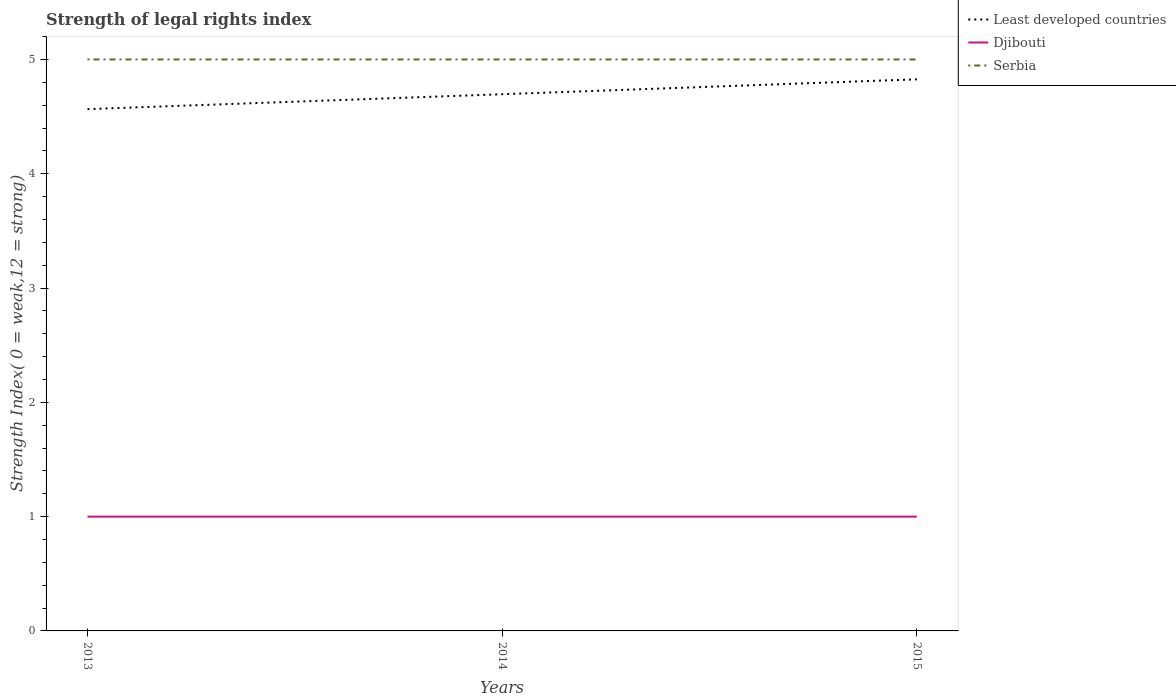Does the line corresponding to Least developed countries intersect with the line corresponding to Djibouti?
Provide a succinct answer. No. Is the number of lines equal to the number of legend labels?
Offer a very short reply. Yes. Across all years, what is the maximum strength index in Djibouti?
Provide a short and direct response. 1. What is the total strength index in Least developed countries in the graph?
Give a very brief answer. -0.26. What is the difference between the highest and the second highest strength index in Least developed countries?
Give a very brief answer. 0.26. What is the difference between the highest and the lowest strength index in Djibouti?
Give a very brief answer. 0. Is the strength index in Least developed countries strictly greater than the strength index in Djibouti over the years?
Ensure brevity in your answer.  No. How many lines are there?
Ensure brevity in your answer.  3. How many years are there in the graph?
Ensure brevity in your answer.  3. Does the graph contain any zero values?
Your answer should be compact. No. Where does the legend appear in the graph?
Your answer should be compact. Top right. How many legend labels are there?
Give a very brief answer. 3. What is the title of the graph?
Keep it short and to the point. Strength of legal rights index. Does "Caribbean small states" appear as one of the legend labels in the graph?
Offer a terse response. No. What is the label or title of the X-axis?
Your answer should be very brief. Years. What is the label or title of the Y-axis?
Offer a terse response. Strength Index( 0 = weak,12 = strong). What is the Strength Index( 0 = weak,12 = strong) in Least developed countries in 2013?
Your response must be concise. 4.57. What is the Strength Index( 0 = weak,12 = strong) in Djibouti in 2013?
Your answer should be very brief. 1. What is the Strength Index( 0 = weak,12 = strong) of Least developed countries in 2014?
Offer a very short reply. 4.7. What is the Strength Index( 0 = weak,12 = strong) in Serbia in 2014?
Give a very brief answer. 5. What is the Strength Index( 0 = weak,12 = strong) in Least developed countries in 2015?
Keep it short and to the point. 4.83. What is the Strength Index( 0 = weak,12 = strong) in Djibouti in 2015?
Your answer should be compact. 1. Across all years, what is the maximum Strength Index( 0 = weak,12 = strong) in Least developed countries?
Offer a very short reply. 4.83. Across all years, what is the maximum Strength Index( 0 = weak,12 = strong) of Djibouti?
Provide a short and direct response. 1. Across all years, what is the maximum Strength Index( 0 = weak,12 = strong) of Serbia?
Your answer should be very brief. 5. Across all years, what is the minimum Strength Index( 0 = weak,12 = strong) of Least developed countries?
Provide a succinct answer. 4.57. Across all years, what is the minimum Strength Index( 0 = weak,12 = strong) in Djibouti?
Ensure brevity in your answer.  1. What is the total Strength Index( 0 = weak,12 = strong) in Least developed countries in the graph?
Offer a terse response. 14.09. What is the total Strength Index( 0 = weak,12 = strong) in Djibouti in the graph?
Provide a short and direct response. 3. What is the total Strength Index( 0 = weak,12 = strong) of Serbia in the graph?
Give a very brief answer. 15. What is the difference between the Strength Index( 0 = weak,12 = strong) in Least developed countries in 2013 and that in 2014?
Provide a succinct answer. -0.13. What is the difference between the Strength Index( 0 = weak,12 = strong) in Djibouti in 2013 and that in 2014?
Make the answer very short. 0. What is the difference between the Strength Index( 0 = weak,12 = strong) of Least developed countries in 2013 and that in 2015?
Make the answer very short. -0.26. What is the difference between the Strength Index( 0 = weak,12 = strong) of Serbia in 2013 and that in 2015?
Keep it short and to the point. 0. What is the difference between the Strength Index( 0 = weak,12 = strong) in Least developed countries in 2014 and that in 2015?
Your answer should be very brief. -0.13. What is the difference between the Strength Index( 0 = weak,12 = strong) of Djibouti in 2014 and that in 2015?
Provide a succinct answer. 0. What is the difference between the Strength Index( 0 = weak,12 = strong) in Least developed countries in 2013 and the Strength Index( 0 = weak,12 = strong) in Djibouti in 2014?
Offer a terse response. 3.57. What is the difference between the Strength Index( 0 = weak,12 = strong) in Least developed countries in 2013 and the Strength Index( 0 = weak,12 = strong) in Serbia in 2014?
Your answer should be compact. -0.43. What is the difference between the Strength Index( 0 = weak,12 = strong) in Least developed countries in 2013 and the Strength Index( 0 = weak,12 = strong) in Djibouti in 2015?
Your response must be concise. 3.57. What is the difference between the Strength Index( 0 = weak,12 = strong) in Least developed countries in 2013 and the Strength Index( 0 = weak,12 = strong) in Serbia in 2015?
Offer a terse response. -0.43. What is the difference between the Strength Index( 0 = weak,12 = strong) in Least developed countries in 2014 and the Strength Index( 0 = weak,12 = strong) in Djibouti in 2015?
Offer a terse response. 3.7. What is the difference between the Strength Index( 0 = weak,12 = strong) in Least developed countries in 2014 and the Strength Index( 0 = weak,12 = strong) in Serbia in 2015?
Offer a very short reply. -0.3. What is the difference between the Strength Index( 0 = weak,12 = strong) in Djibouti in 2014 and the Strength Index( 0 = weak,12 = strong) in Serbia in 2015?
Keep it short and to the point. -4. What is the average Strength Index( 0 = weak,12 = strong) in Least developed countries per year?
Keep it short and to the point. 4.7. What is the average Strength Index( 0 = weak,12 = strong) of Serbia per year?
Make the answer very short. 5. In the year 2013, what is the difference between the Strength Index( 0 = weak,12 = strong) in Least developed countries and Strength Index( 0 = weak,12 = strong) in Djibouti?
Provide a short and direct response. 3.57. In the year 2013, what is the difference between the Strength Index( 0 = weak,12 = strong) of Least developed countries and Strength Index( 0 = weak,12 = strong) of Serbia?
Ensure brevity in your answer.  -0.43. In the year 2014, what is the difference between the Strength Index( 0 = weak,12 = strong) in Least developed countries and Strength Index( 0 = weak,12 = strong) in Djibouti?
Keep it short and to the point. 3.7. In the year 2014, what is the difference between the Strength Index( 0 = weak,12 = strong) of Least developed countries and Strength Index( 0 = weak,12 = strong) of Serbia?
Your response must be concise. -0.3. In the year 2014, what is the difference between the Strength Index( 0 = weak,12 = strong) in Djibouti and Strength Index( 0 = weak,12 = strong) in Serbia?
Provide a short and direct response. -4. In the year 2015, what is the difference between the Strength Index( 0 = weak,12 = strong) of Least developed countries and Strength Index( 0 = weak,12 = strong) of Djibouti?
Provide a short and direct response. 3.83. In the year 2015, what is the difference between the Strength Index( 0 = weak,12 = strong) of Least developed countries and Strength Index( 0 = weak,12 = strong) of Serbia?
Make the answer very short. -0.17. In the year 2015, what is the difference between the Strength Index( 0 = weak,12 = strong) in Djibouti and Strength Index( 0 = weak,12 = strong) in Serbia?
Your response must be concise. -4. What is the ratio of the Strength Index( 0 = weak,12 = strong) of Least developed countries in 2013 to that in 2014?
Ensure brevity in your answer.  0.97. What is the ratio of the Strength Index( 0 = weak,12 = strong) of Djibouti in 2013 to that in 2014?
Ensure brevity in your answer.  1. What is the ratio of the Strength Index( 0 = weak,12 = strong) in Serbia in 2013 to that in 2014?
Provide a short and direct response. 1. What is the ratio of the Strength Index( 0 = weak,12 = strong) in Least developed countries in 2013 to that in 2015?
Offer a terse response. 0.95. What is the ratio of the Strength Index( 0 = weak,12 = strong) of Serbia in 2013 to that in 2015?
Keep it short and to the point. 1. What is the difference between the highest and the second highest Strength Index( 0 = weak,12 = strong) in Least developed countries?
Keep it short and to the point. 0.13. What is the difference between the highest and the second highest Strength Index( 0 = weak,12 = strong) in Djibouti?
Ensure brevity in your answer.  0. What is the difference between the highest and the second highest Strength Index( 0 = weak,12 = strong) in Serbia?
Keep it short and to the point. 0. What is the difference between the highest and the lowest Strength Index( 0 = weak,12 = strong) of Least developed countries?
Ensure brevity in your answer.  0.26. 